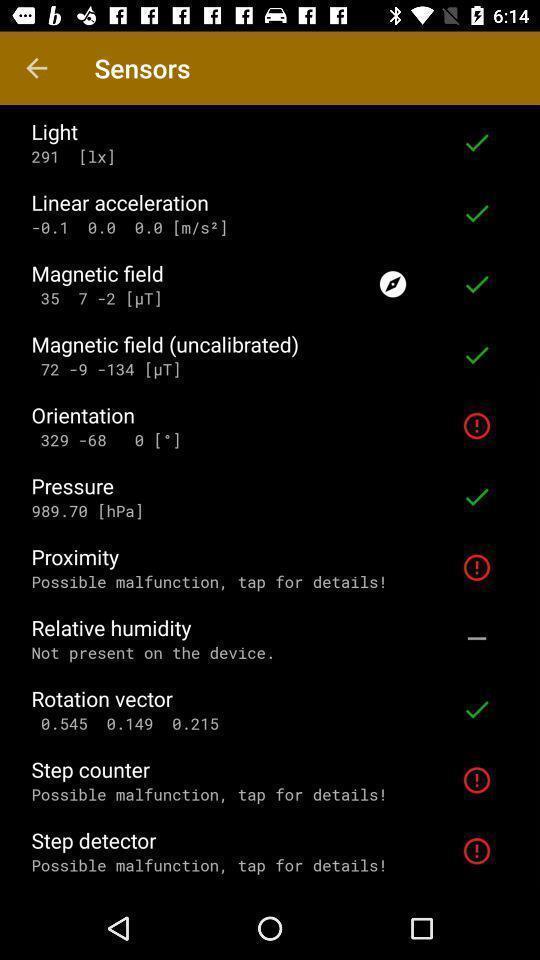Explain the elements present in this screenshot. Page displaying various information. 